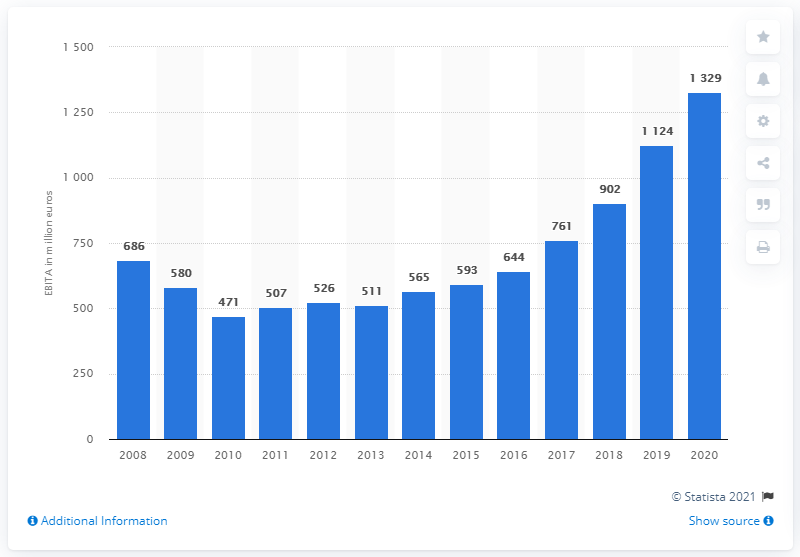Specify some key components in this picture. Universal Music Group's EBITA in the previous year was 902. Universal Music Group's EBITA in 2020 was 1,329. 